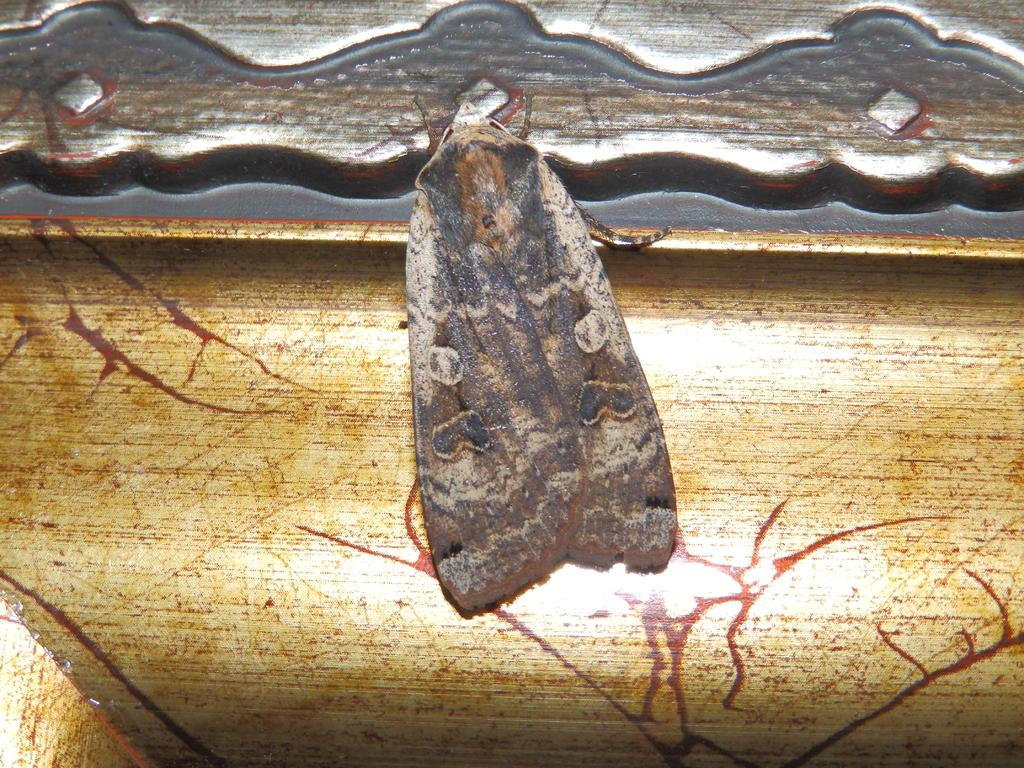What type of creature is present in the image? There is an insect in the image. Can you describe the colors of the insect? The insect has cream, brown, and black colors. What else can be seen in the image besides the insect? There is an object in the image. Can you describe the colors of the object? The object has brown, cream, and silver colors. What type of veil is draped over the insect in the image? There is no veil present in the image; it only features an insect and an object. 